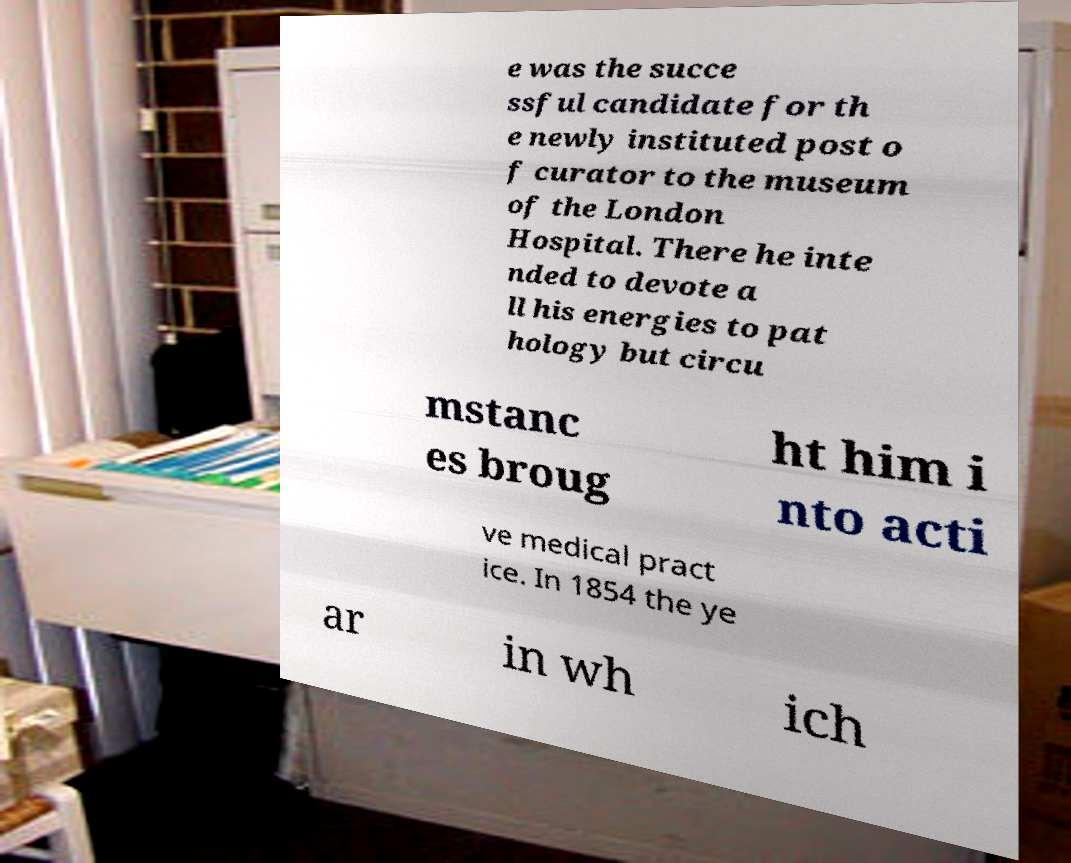Can you accurately transcribe the text from the provided image for me? e was the succe ssful candidate for th e newly instituted post o f curator to the museum of the London Hospital. There he inte nded to devote a ll his energies to pat hology but circu mstanc es broug ht him i nto acti ve medical pract ice. In 1854 the ye ar in wh ich 